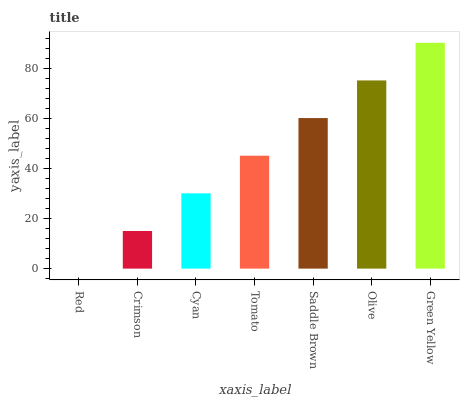Is Red the minimum?
Answer yes or no. Yes. Is Green Yellow the maximum?
Answer yes or no. Yes. Is Crimson the minimum?
Answer yes or no. No. Is Crimson the maximum?
Answer yes or no. No. Is Crimson greater than Red?
Answer yes or no. Yes. Is Red less than Crimson?
Answer yes or no. Yes. Is Red greater than Crimson?
Answer yes or no. No. Is Crimson less than Red?
Answer yes or no. No. Is Tomato the high median?
Answer yes or no. Yes. Is Tomato the low median?
Answer yes or no. Yes. Is Crimson the high median?
Answer yes or no. No. Is Red the low median?
Answer yes or no. No. 